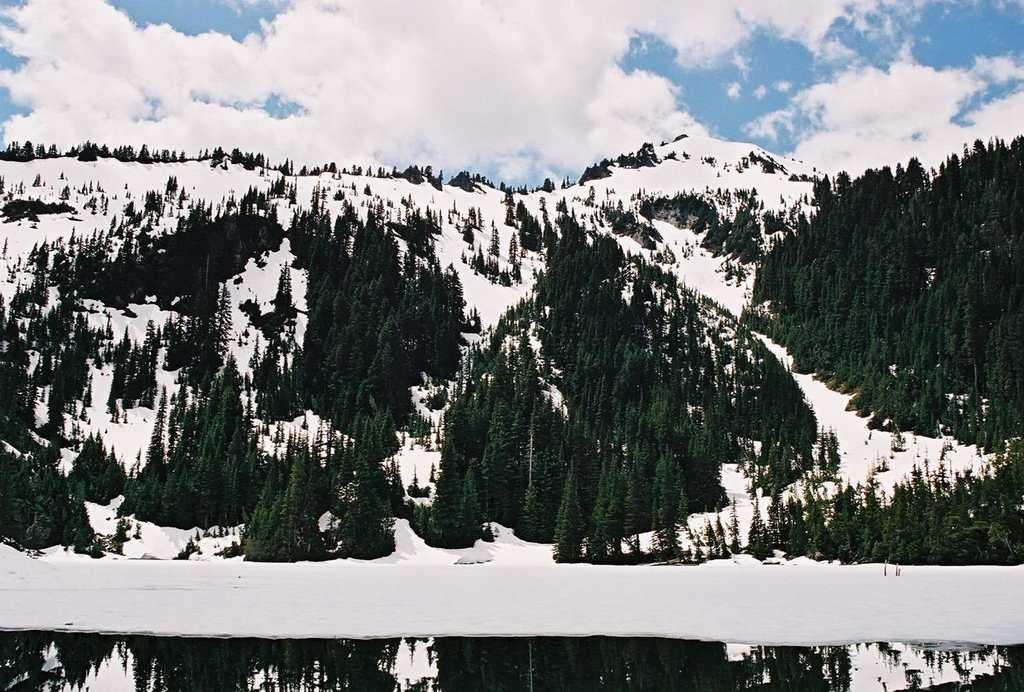What type of vegetation is present in the image? There is a group of trees in the image. What other natural features can be seen in the image? There are ice hills in the image. What is the condition of the sky in the sky in the image? The sky is visible in the image and appears cloudy. What type of terrain is visible at the bottom of the image? There is water visible at the bottom of the image. What type of bread is being read by the trees in the image? There is no bread or reading activity present in the image; it features a group of trees, ice hills, a cloudy sky, and water. How does the image indicate that the trees should stop their activity? There is no indication of any activity or need for the trees to stop in the image. 